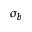<formula> <loc_0><loc_0><loc_500><loc_500>\sigma _ { b }</formula> 